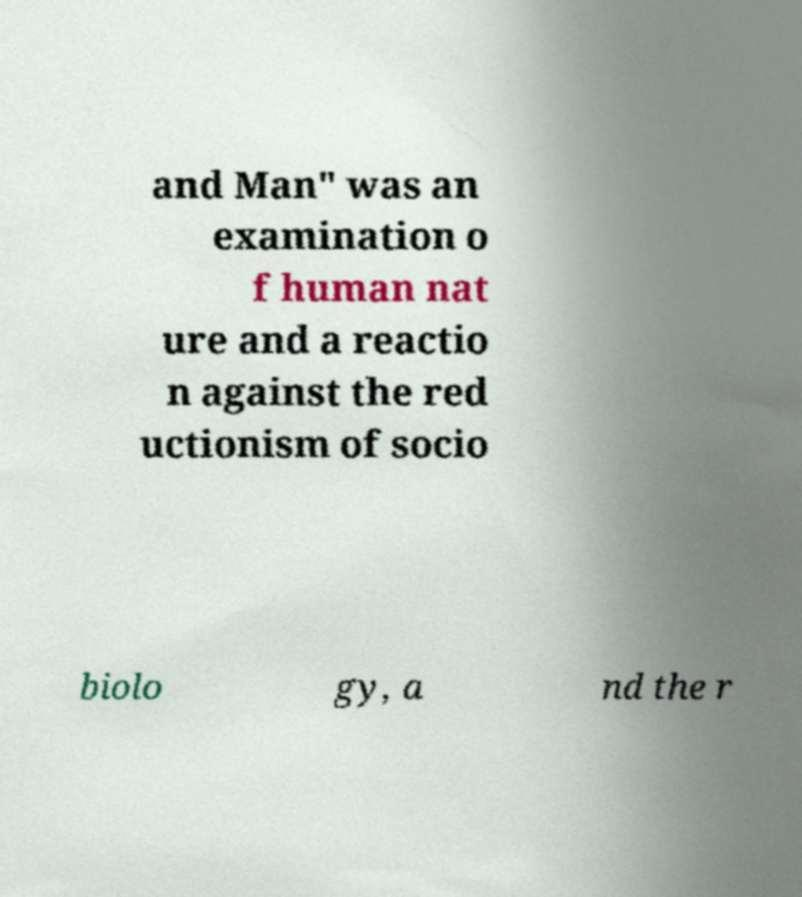For documentation purposes, I need the text within this image transcribed. Could you provide that? and Man" was an examination o f human nat ure and a reactio n against the red uctionism of socio biolo gy, a nd the r 